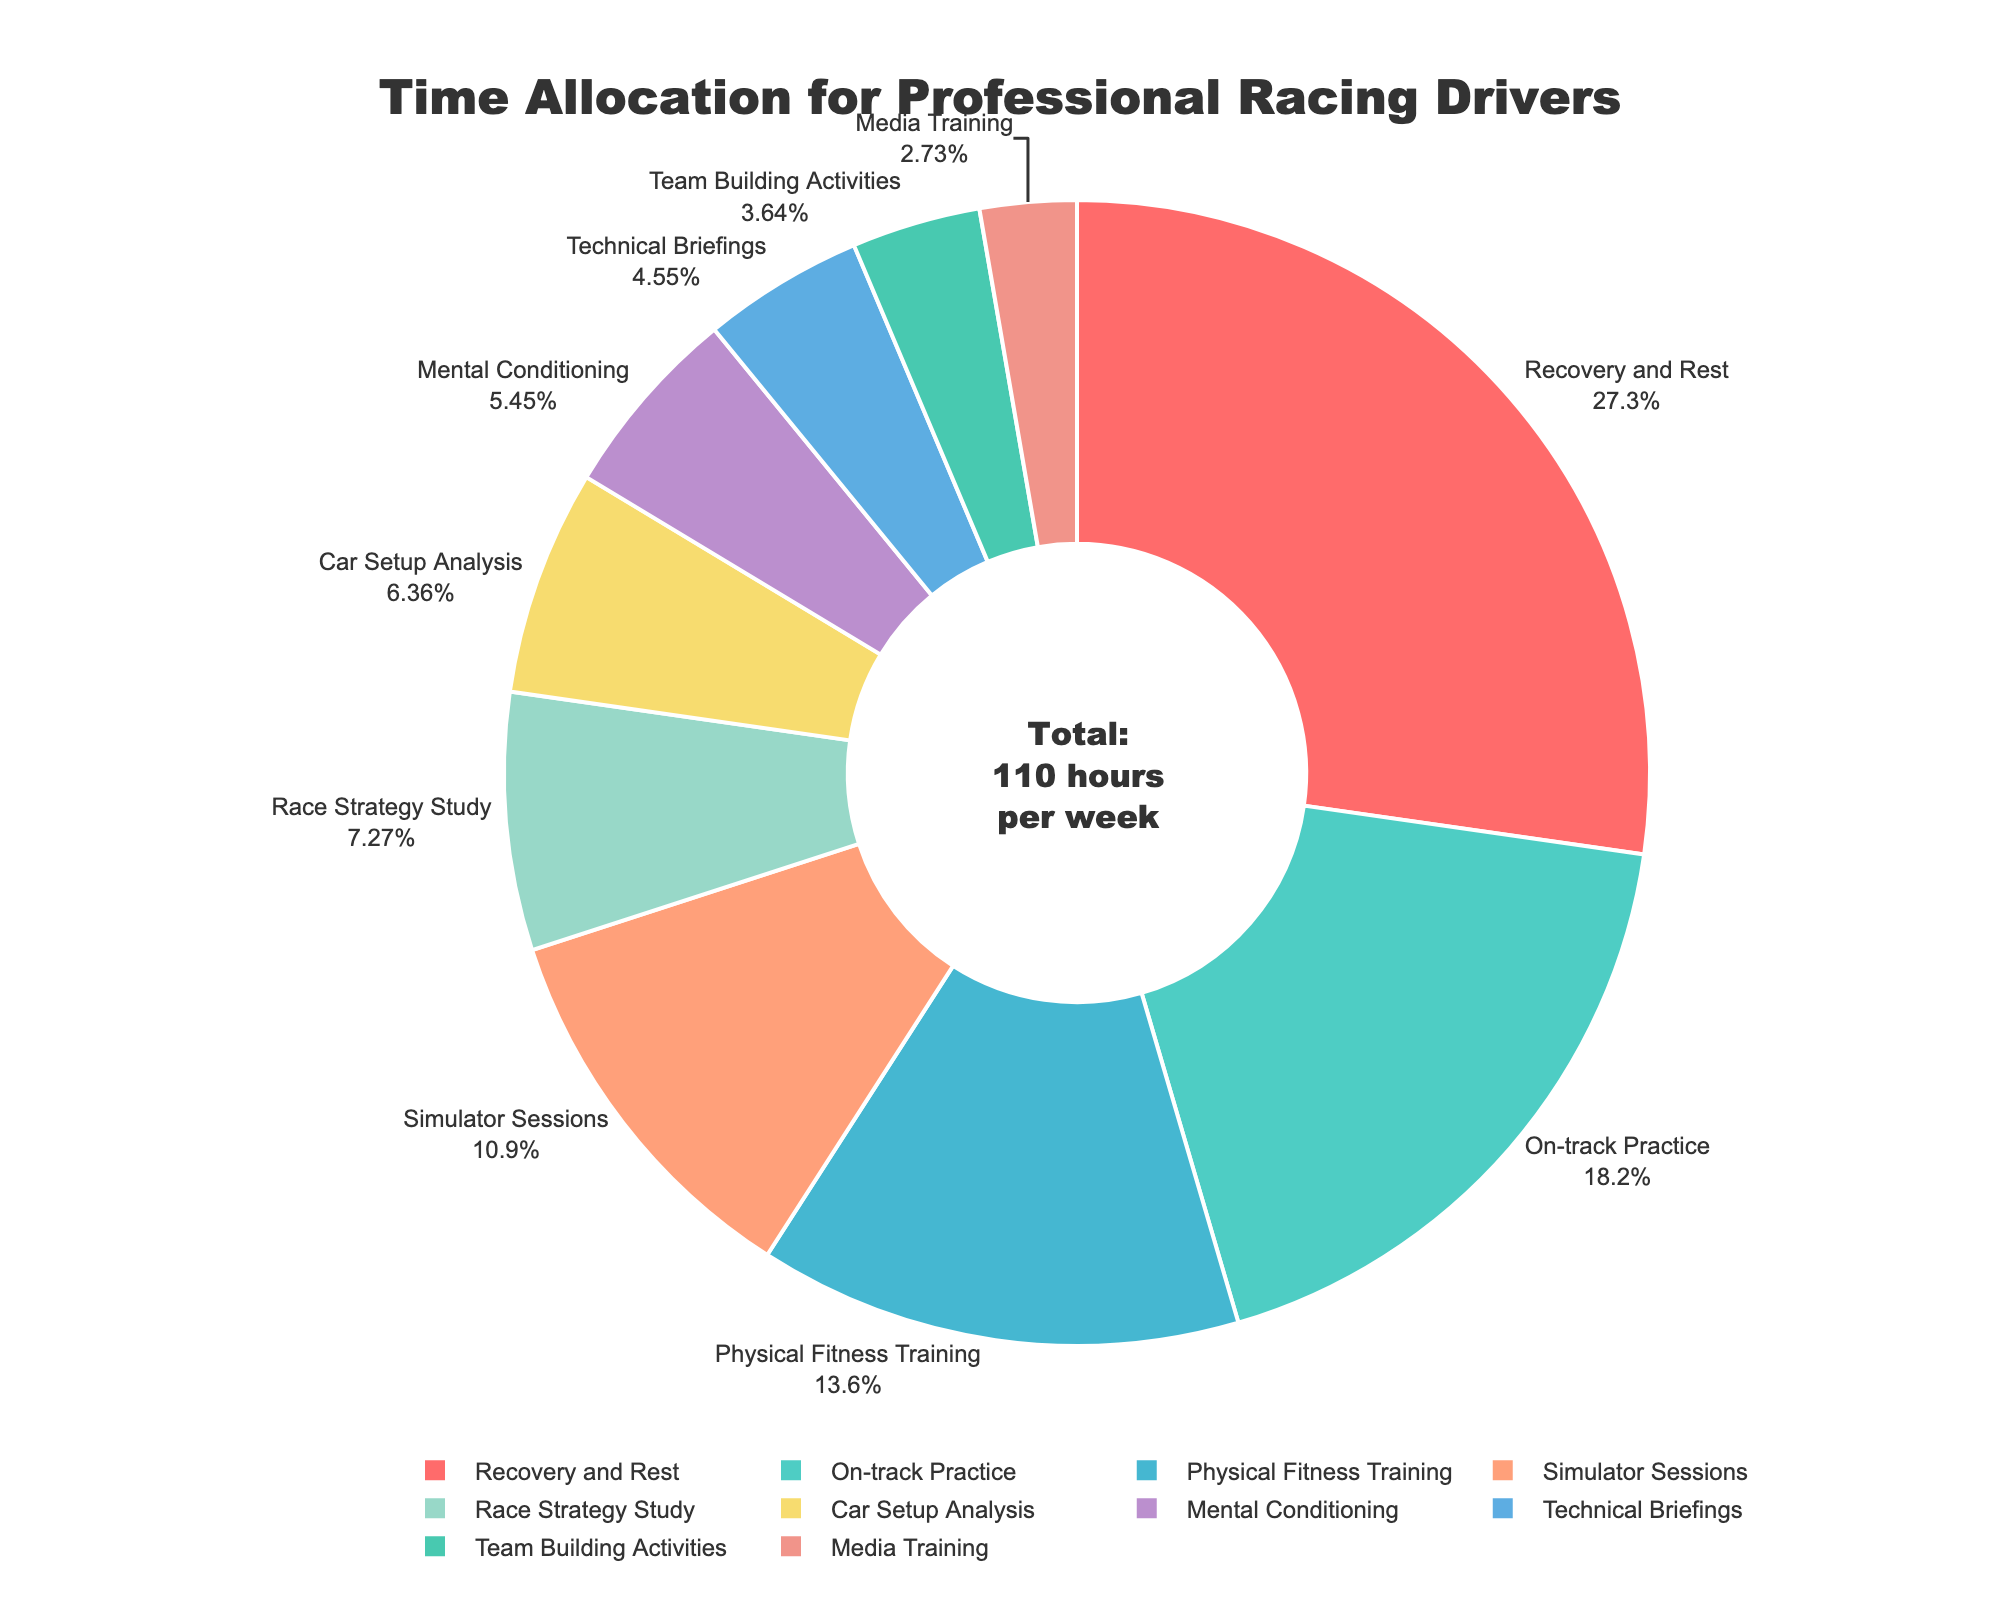1. **Compositional Question**:
- Which two activities combined take up the most time per week? The activities with the highest time allocation are "Recovery and Rest" (30 hours) and "On-track Practice" (20 hours). Adding these together, the combined time is 30 + 20 = 50 hours.
Answer: Recovery and Rest, On-track Practice 2. **Comparison Question**:
- Does Physical Fitness Training take more time than Simulator Sessions? Physical Fitness Training accounts for 15 hours, while Simulator Sessions take 12 hours. Comparing these, 15 hours is greater than 12 hours.
Answer: Yes 3. **Visual Question**:
- What color is used for the segment representing Mental Conditioning? By looking at the pie chart, the segment for Mental Conditioning is represented in a specific color. This color is green.
Answer: Green 4. **Compositional Question**:
- What percentage of the total time is spent on Race Strategy Study and Car Setup Analysis combined? Race Strategy Study takes 8 hours and Car Setup Analysis takes 7 hours. The total is 15 hours. The sum of all hours per week is 110. The combined percentage is (15/110) * 100 = 13.64%.
Answer: 13.64% 5. **Comparison Question**:
- Which activity has the lowest time allocation and how much time is allocated to it? Analyzing the pie chart, Media Training has the smallest segment which corresponds to the lowest allocation of 3 hours.
Answer: Media Training, 3 hours 6. **Visual Question**:
- How is Total Time highlighted in the pie chart? The total time is highlighted in the center of the pie chart with an annotation that reads "Total: 110 hours per week."
Answer: Center annotation 7. **Compositional Question**:
- What is the difference in time allocation between Media Training and Team Building Activities? Media Training is allocated 3 hours, and Team Building Activities are allocated 4 hours. The difference is 4 - 3 = 1 hour.
Answer: 1 hour 8. **Comparison Question**:
- Which is greater: time spent on Technical Briefings or Mental Conditioning? Technical Briefings take 5 hours while Mental Conditioning takes 6 hours. Comparing these, 6 hours is greater.
Answer: Mental Conditioning 9. **Visual Question**:
- Which activity is depicted with the largest segment? The largest segment in the pie chart is for Recovery and Rest.
Answer: Recovery and Rest 10. **Compositional Question**:
- What is the total percentage of time allocated to On-track Practice, Simulator Sessions, and Recovery and Rest? On-track Practice is 20%, Simulator Sessions are around 10.91%, and Recovery and Rest is about 27.27%. Summing these, 20 + 10.91 + 27.27 = 58.18%.
Answer: 58.18% 